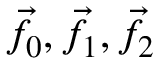<formula> <loc_0><loc_0><loc_500><loc_500>{ \vec { f } } \, _ { 0 } , { \vec { f } } \, _ { 1 } , { \vec { f } } \, _ { 2 }</formula> 